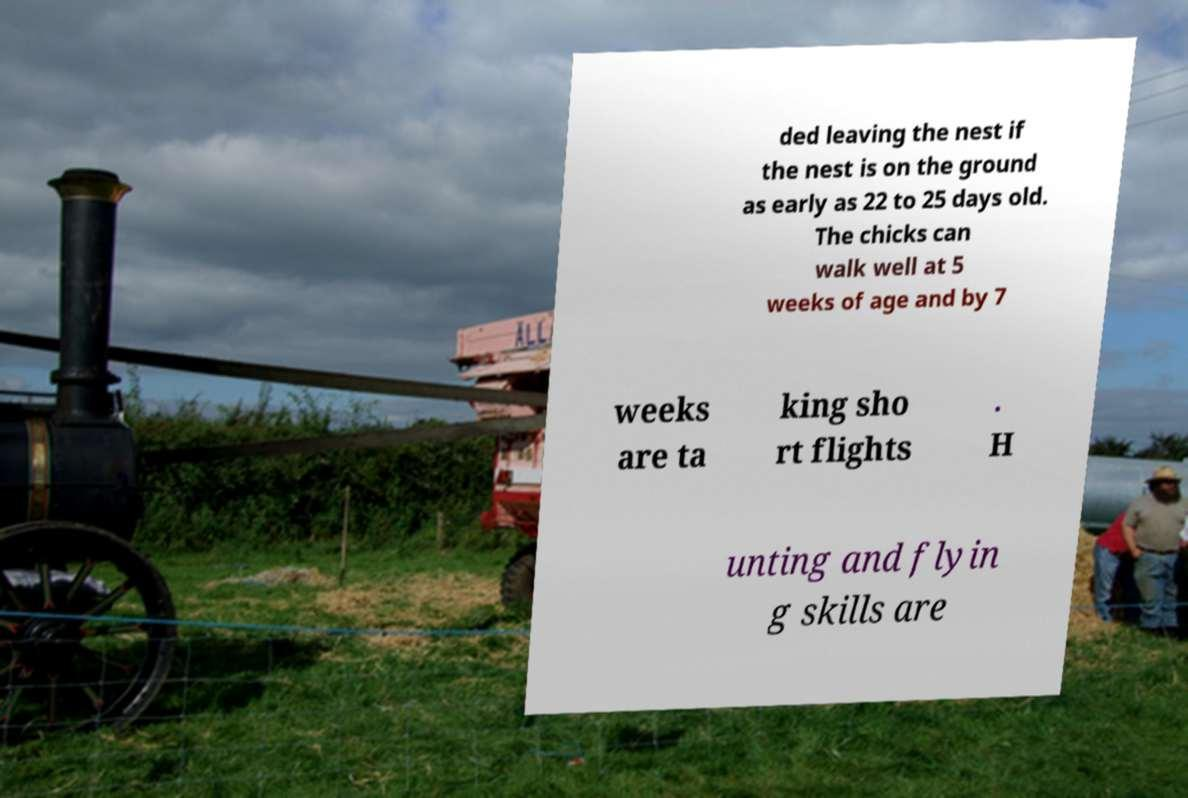What messages or text are displayed in this image? I need them in a readable, typed format. ded leaving the nest if the nest is on the ground as early as 22 to 25 days old. The chicks can walk well at 5 weeks of age and by 7 weeks are ta king sho rt flights . H unting and flyin g skills are 